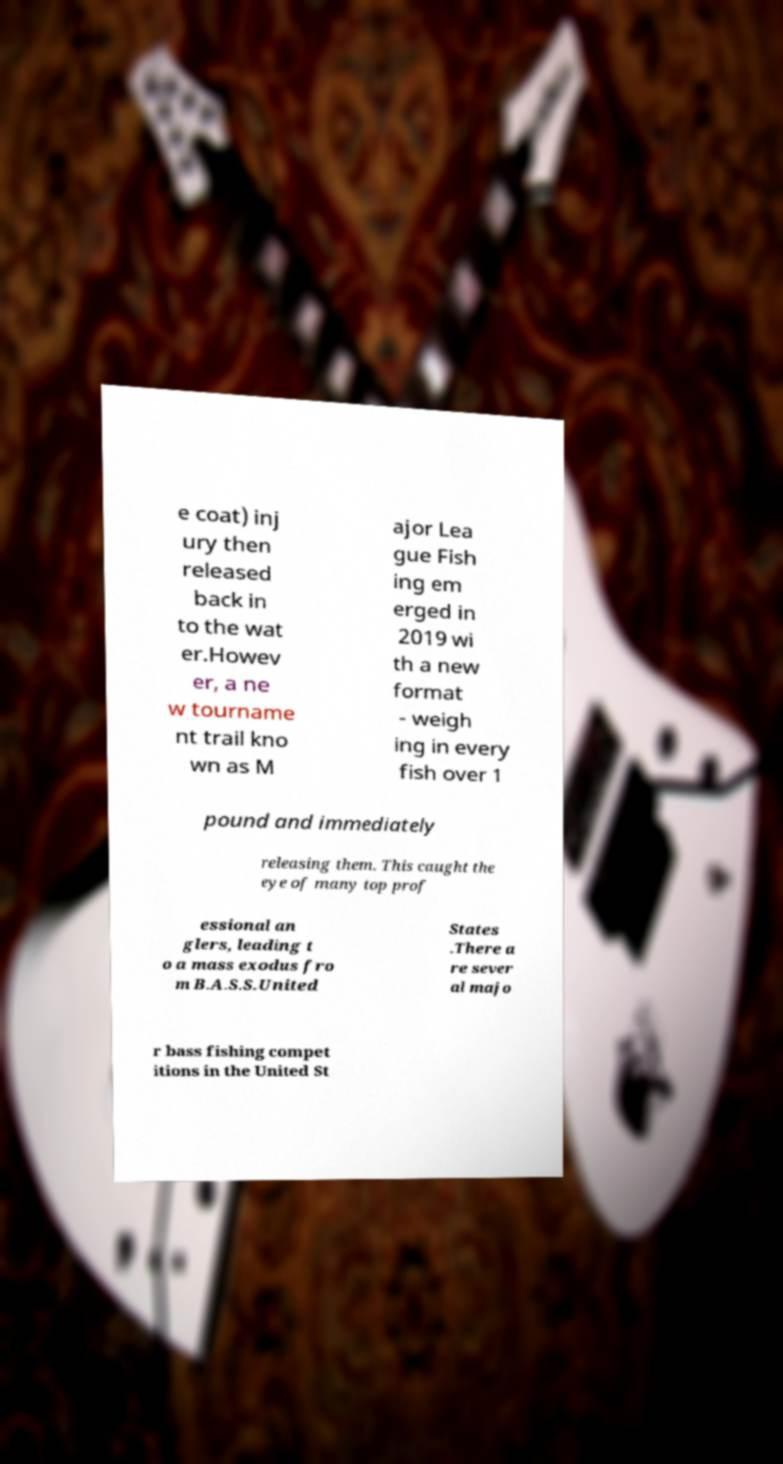What messages or text are displayed in this image? I need them in a readable, typed format. e coat) inj ury then released back in to the wat er.Howev er, a ne w tourname nt trail kno wn as M ajor Lea gue Fish ing em erged in 2019 wi th a new format - weigh ing in every fish over 1 pound and immediately releasing them. This caught the eye of many top prof essional an glers, leading t o a mass exodus fro m B.A.S.S.United States .There a re sever al majo r bass fishing compet itions in the United St 